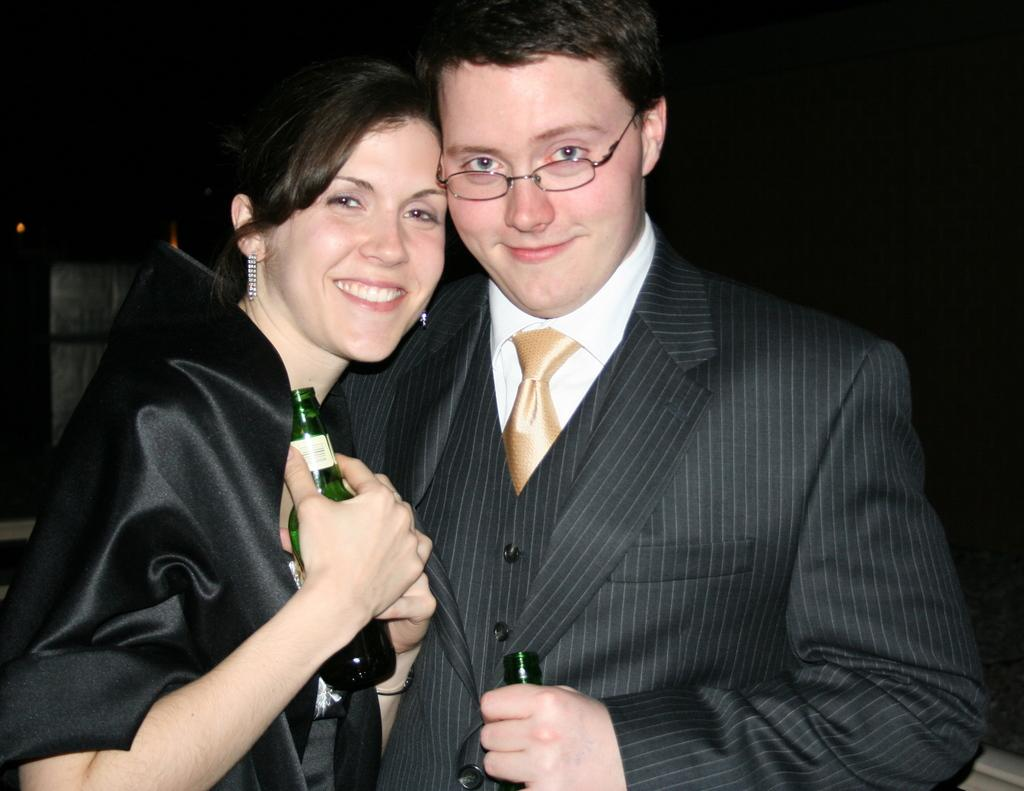What types of people are present in the image? There are women and men in the image. What color of dress are the people wearing? Both the women and men are wearing black color dress. What accessory can be seen on the men in the image? The men are wearing glasses. What are the women and men holding in their hands? Both the women and men are holding a bottle in their hands. How many girls are present in the image? There is no mention of girls in the image; it features both women and men. What type of footwear can be seen on the women in the image? There is no information about footwear in the image; only the color of their dress and the presence of glasses on the men are mentioned. 